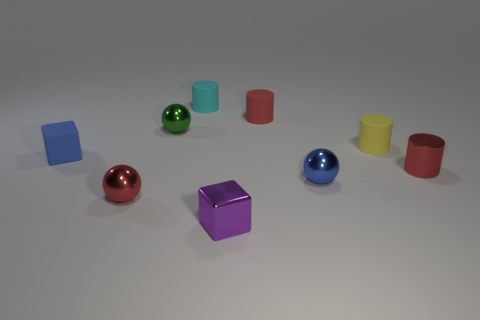How many blocks are tiny cyan objects or purple metal things?
Your answer should be compact. 1. There is a cube in front of the tiny matte cube left of the purple metal block; what number of red things are on the right side of it?
Offer a terse response. 2. There is a metal cylinder that is the same size as the yellow rubber thing; what is its color?
Offer a terse response. Red. What number of other objects are there of the same color as the tiny metal cylinder?
Make the answer very short. 2. Are there more small blue balls that are behind the green sphere than tiny cyan objects?
Ensure brevity in your answer.  No. Do the small blue cube and the cyan thing have the same material?
Keep it short and to the point. Yes. How many things are balls that are in front of the yellow matte thing or yellow matte things?
Offer a terse response. 3. What number of other things are there of the same size as the blue rubber block?
Your response must be concise. 8. Are there an equal number of red matte objects that are to the left of the metallic block and tiny cylinders that are in front of the green shiny sphere?
Offer a terse response. No. What color is the other thing that is the same shape as the tiny blue matte object?
Make the answer very short. Purple. 